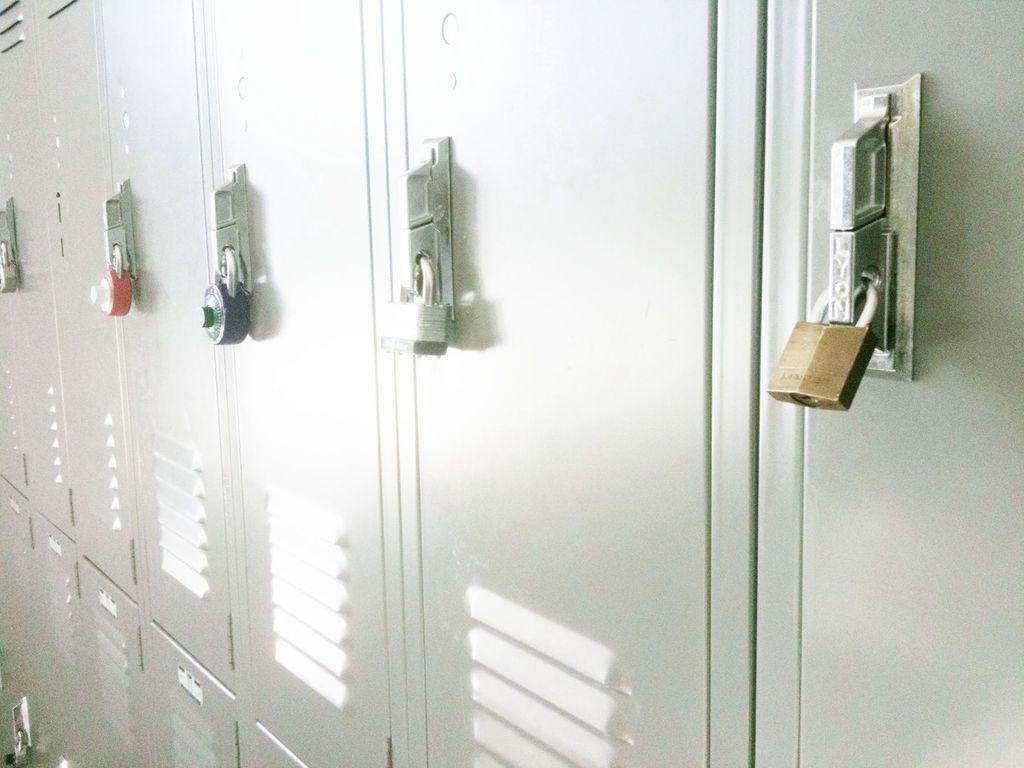What type of storage units are present in the image? There are lockers in the image. What color are the lockers? The lockers are in ash color. Are there any security features on the lockers? Yes, there are locks on the lockers. What colors are the locks? The locks are in red, blue, white, and brown colors. How many sisters are playing with a toy on the lockers in the image? There are no sisters or toys present in the image; it only features lockers with locks. 